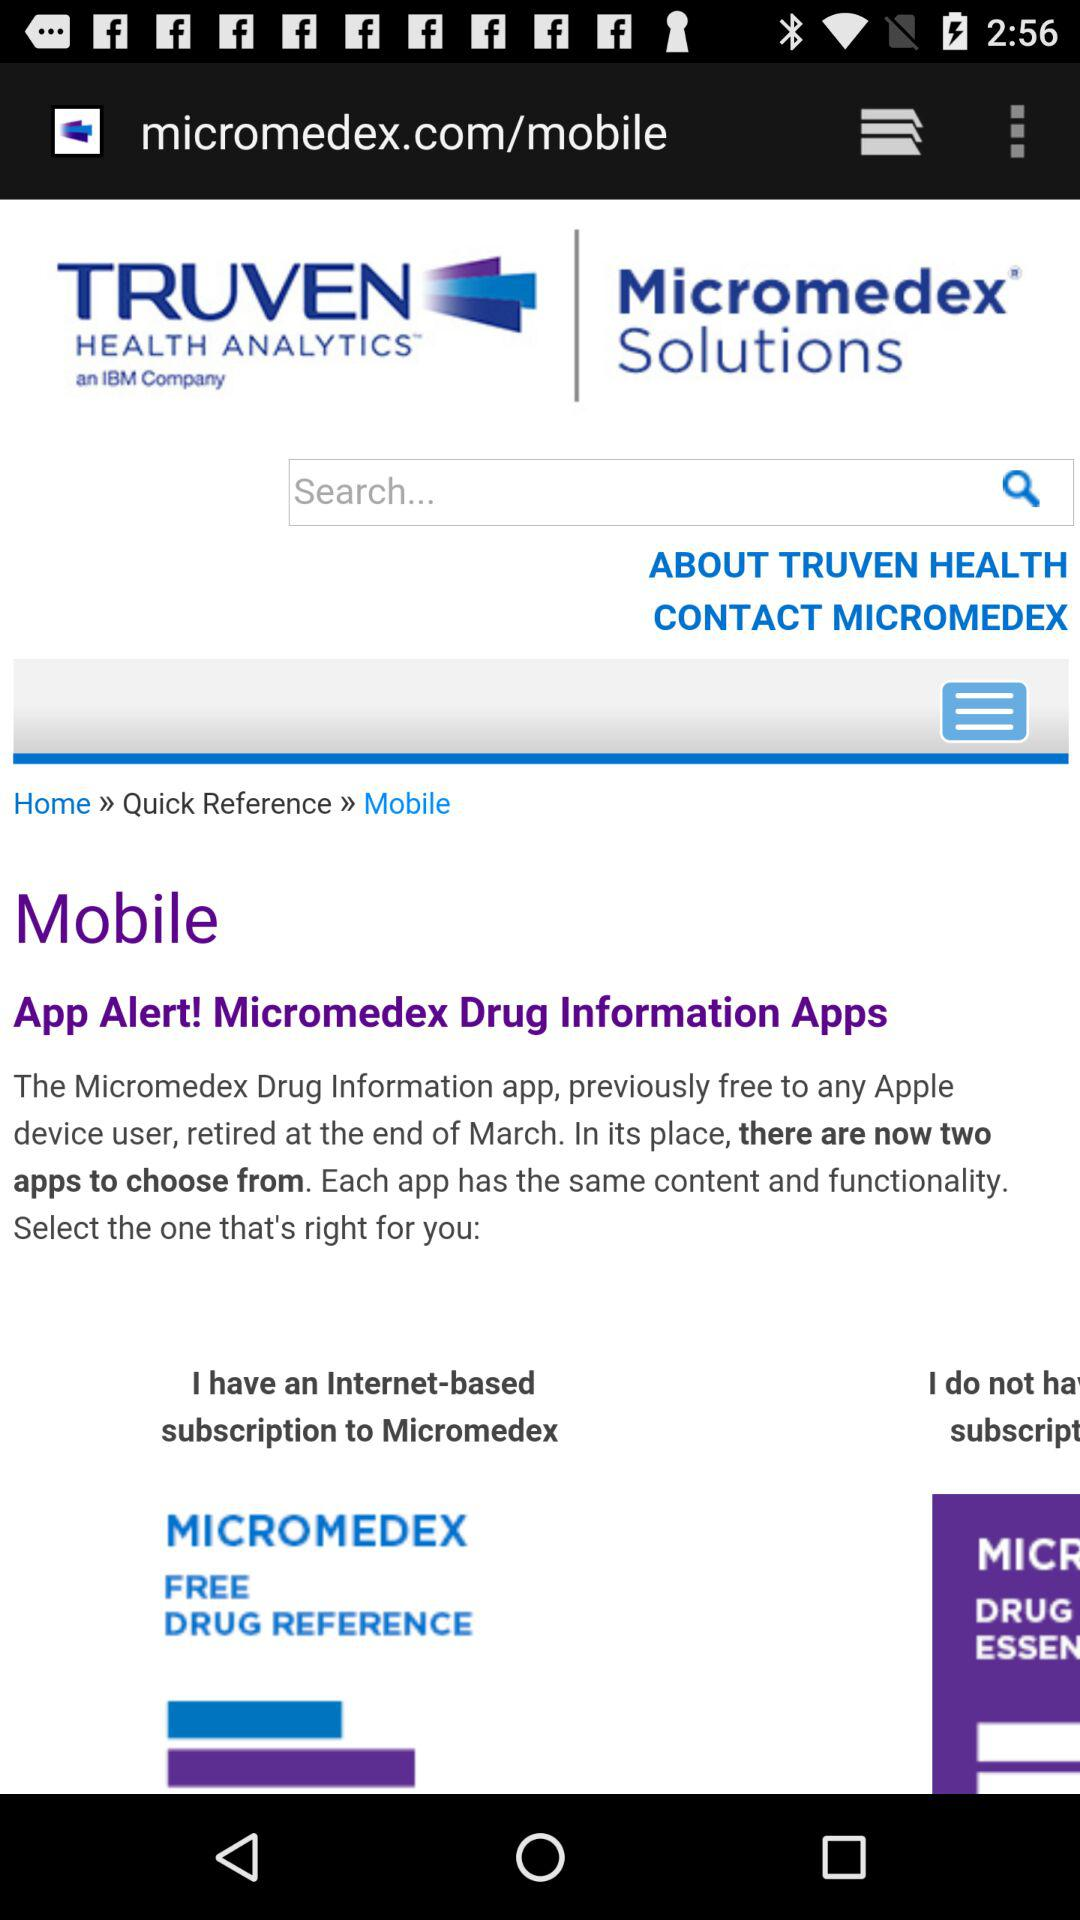When was the "Micromedex Drug Information" application retired? The "Micromedex Drug Information" application was retired at the end of March. 